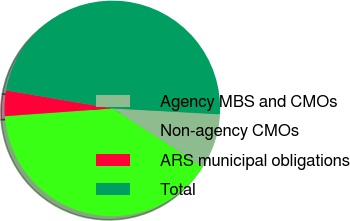Convert chart to OTSL. <chart><loc_0><loc_0><loc_500><loc_500><pie_chart><fcel>Agency MBS and CMOs<fcel>Non-agency CMOs<fcel>ARS municipal obligations<fcel>Total<nl><fcel>8.27%<fcel>39.72%<fcel>3.83%<fcel>48.19%<nl></chart> 